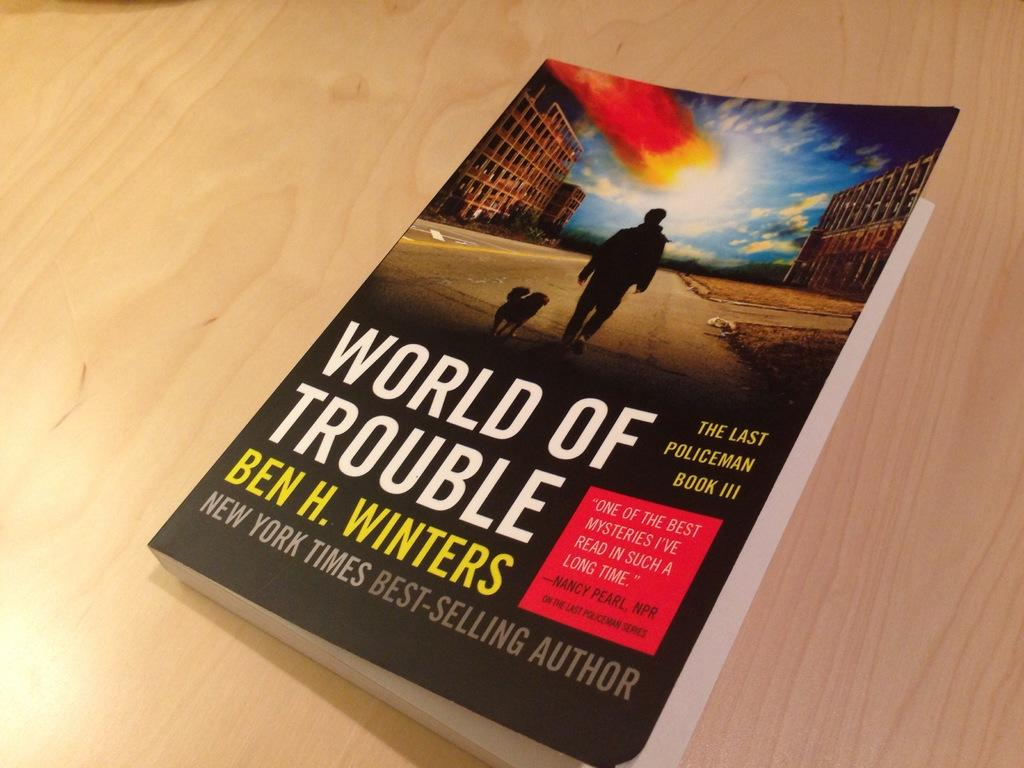<image>
Render a clear and concise summary of the photo. A soft back has the title world of trouble written on it. 